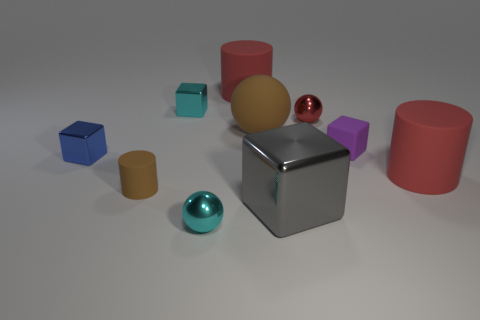Subtract all green blocks. How many red cylinders are left? 2 Subtract all red cylinders. How many cylinders are left? 1 Subtract all purple blocks. How many blocks are left? 3 Subtract 1 balls. How many balls are left? 2 Subtract all balls. How many objects are left? 7 Subtract all green balls. Subtract all blue cylinders. How many balls are left? 3 Add 9 small cyan blocks. How many small cyan blocks are left? 10 Add 5 red matte cylinders. How many red matte cylinders exist? 7 Subtract 2 red cylinders. How many objects are left? 8 Subtract all small blue rubber cylinders. Subtract all cyan balls. How many objects are left? 9 